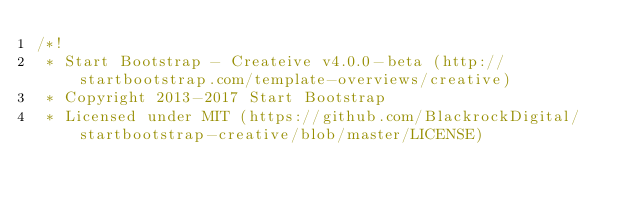Convert code to text. <code><loc_0><loc_0><loc_500><loc_500><_CSS_>/*!
 * Start Bootstrap - Createive v4.0.0-beta (http://startbootstrap.com/template-overviews/creative)
 * Copyright 2013-2017 Start Bootstrap
 * Licensed under MIT (https://github.com/BlackrockDigital/startbootstrap-creative/blob/master/LICENSE)</code> 